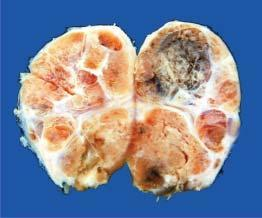does the corresponding area show multiple nodules separated from each other by incomplete fibrous septa?
Answer the question using a single word or phrase. No 